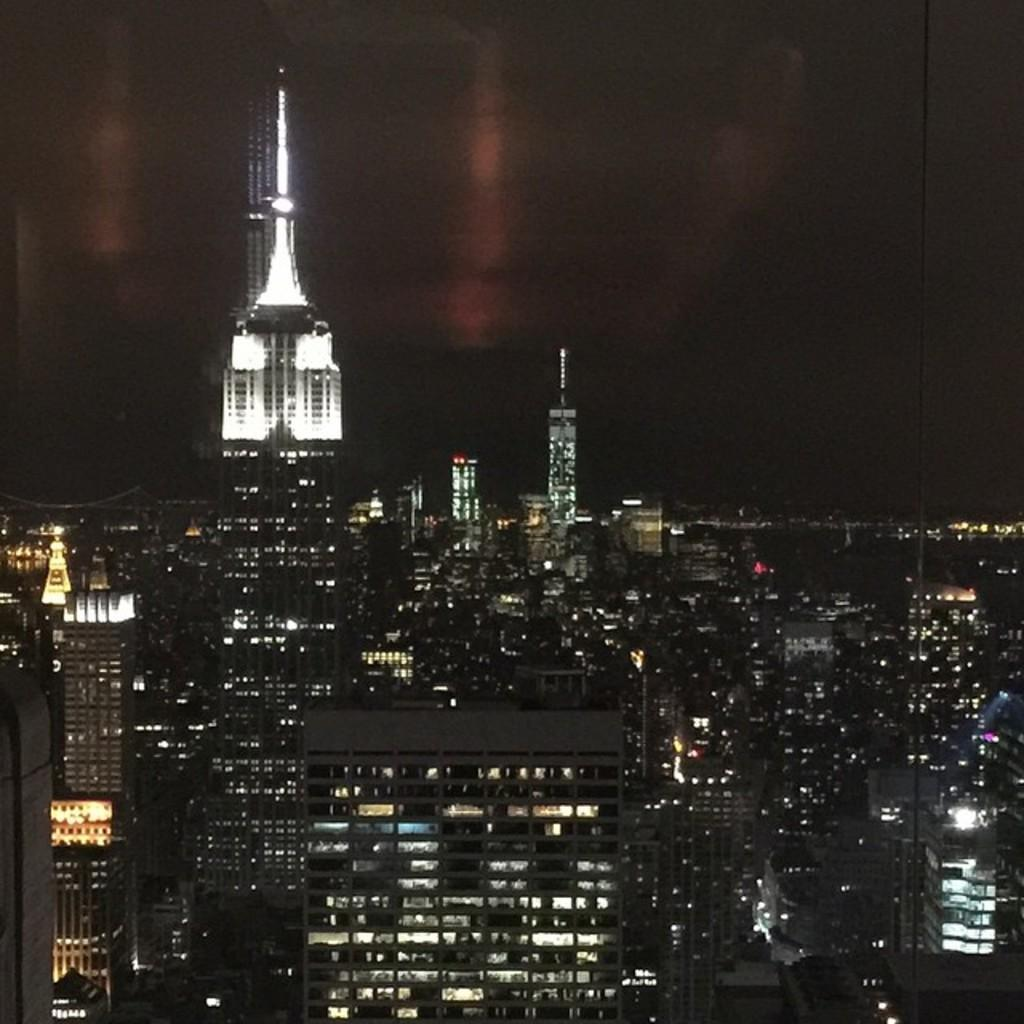What type of structures are located at the bottom of the image? There are buildings and towers at the bottom of the image. What can be seen in the background of the image? There is sky visible at the top of the image. What objects are present in the image that emit light? There are lights in the image. What type of vertical structures can be seen in the image? There are poles in the image. What type of patch is being applied to the structure in the image? There is no patch being applied to any structure in the image. How many screws are visible on the structure in the image? There are no screws visible in the image. 